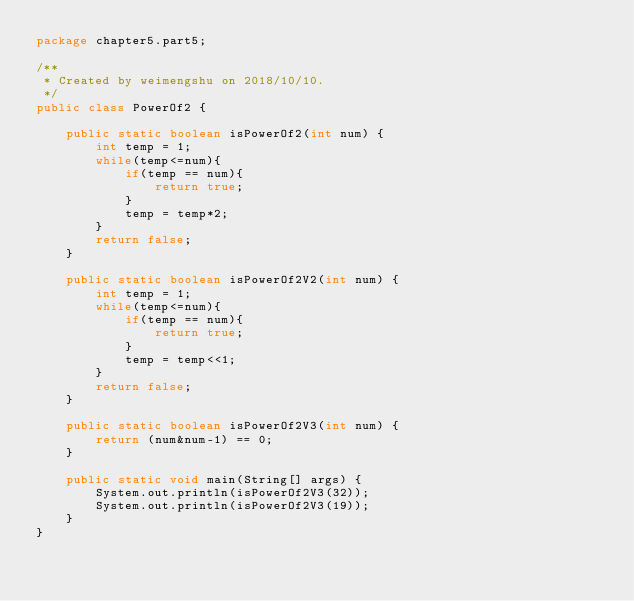Convert code to text. <code><loc_0><loc_0><loc_500><loc_500><_Java_>package chapter5.part5;

/**
 * Created by weimengshu on 2018/10/10.
 */
public class PowerOf2 {

    public static boolean isPowerOf2(int num) {
        int temp = 1;
        while(temp<=num){
            if(temp == num){
                return true;
            }
            temp = temp*2;
        }
        return false;
    }

    public static boolean isPowerOf2V2(int num) {
        int temp = 1;
        while(temp<=num){
            if(temp == num){
                return true;
            }
            temp = temp<<1;
        }
        return false;
    }

    public static boolean isPowerOf2V3(int num) {
        return (num&num-1) == 0;
    }

    public static void main(String[] args) {
        System.out.println(isPowerOf2V3(32));
        System.out.println(isPowerOf2V3(19));
    }
}
</code> 